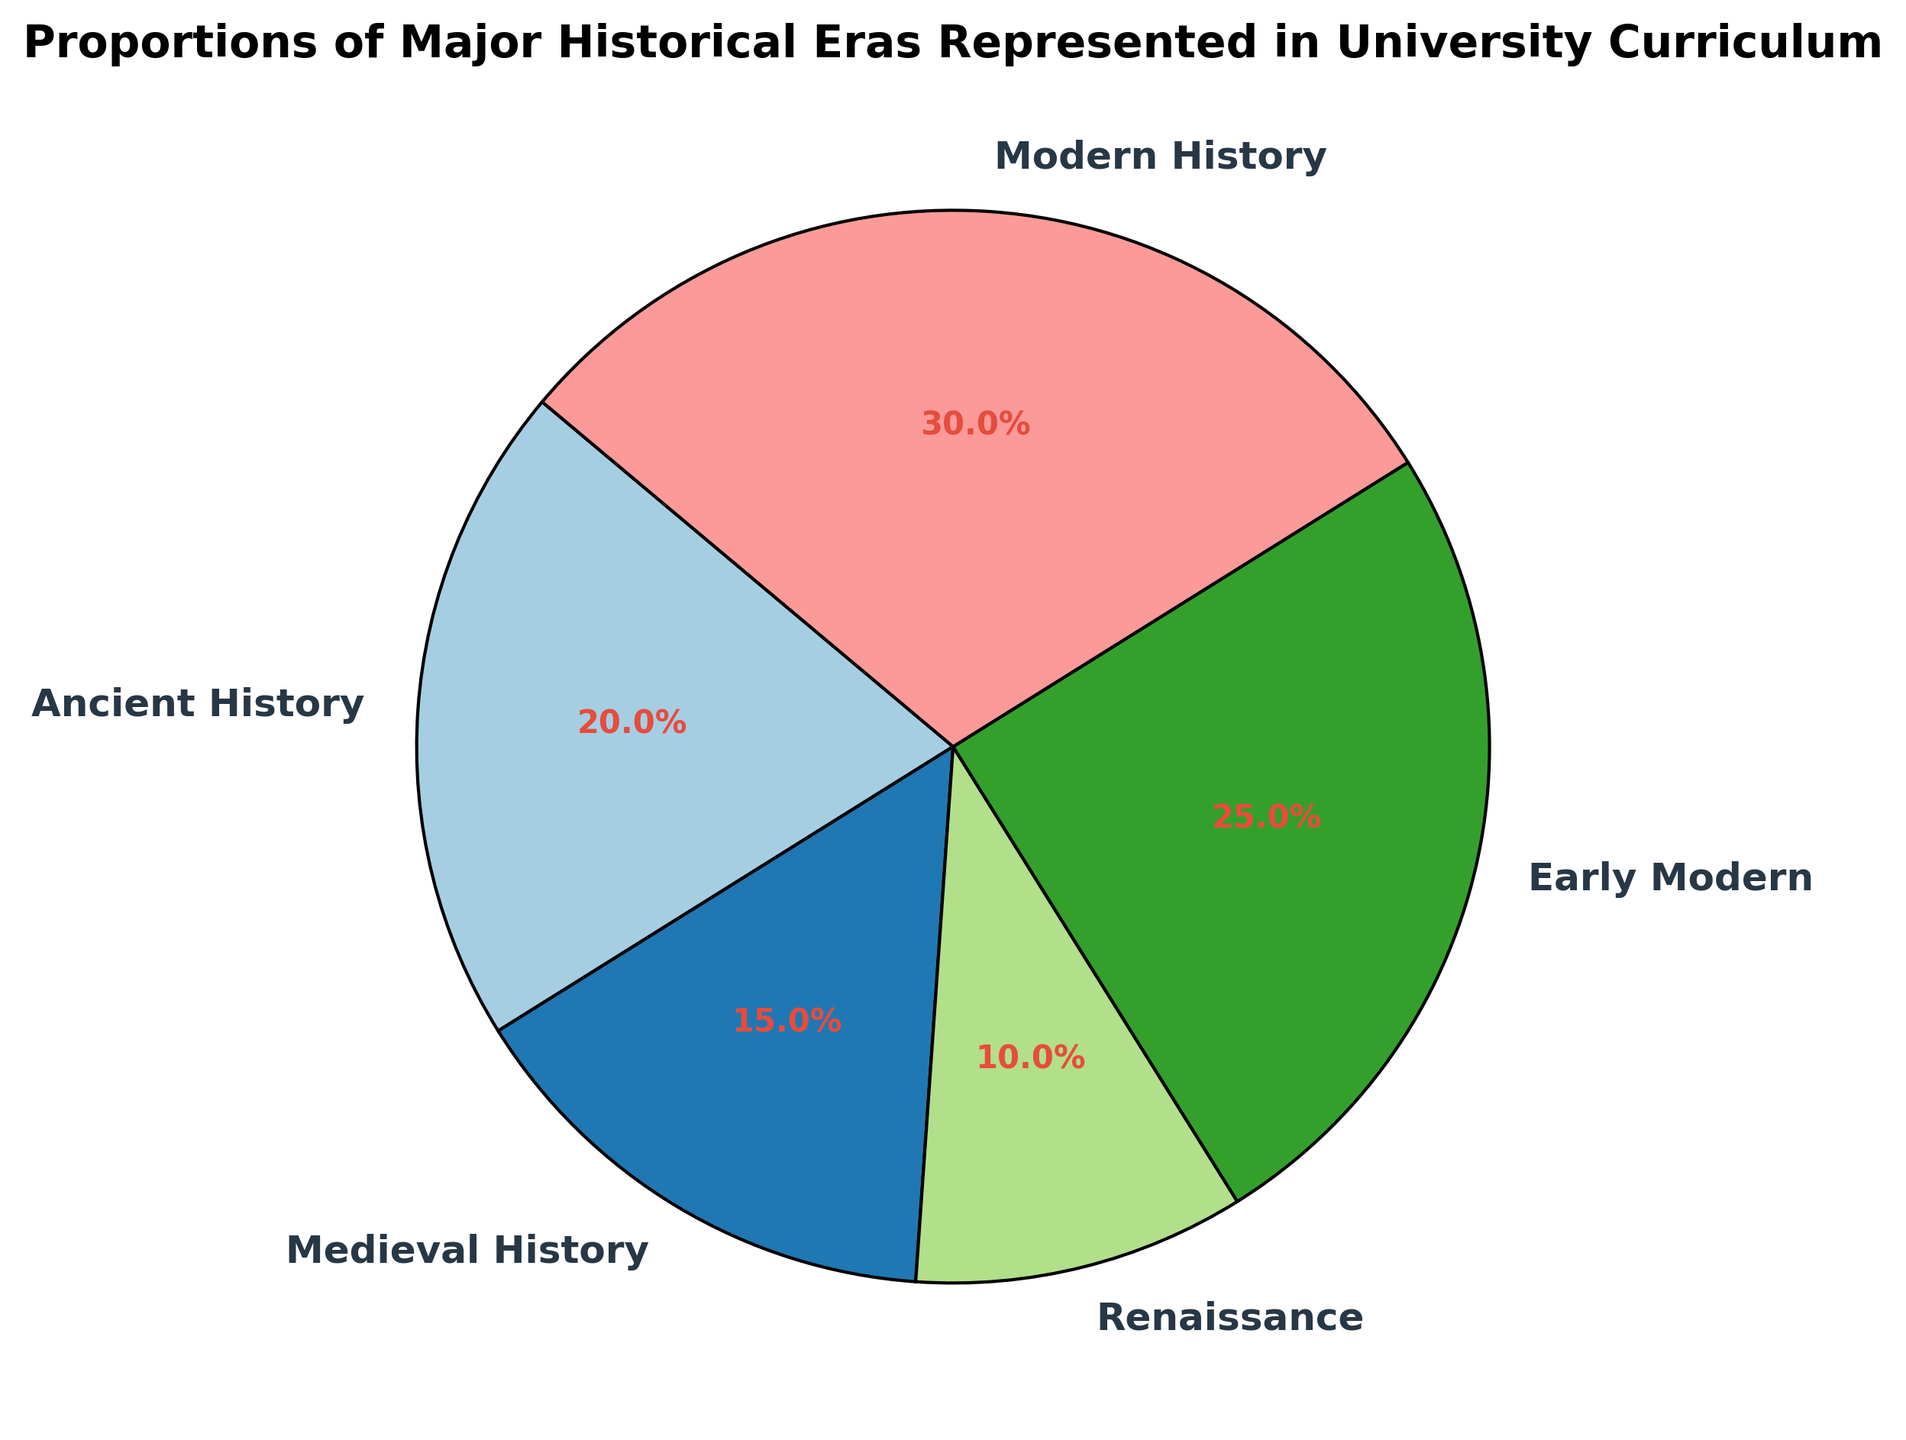What percentage of the curriculum is dedicated to the Renaissance era? The Renaissance era is represented by a segment in the pie chart labeled "Renaissance" with a percentage marked.
Answer: 10% Which era has the highest representation in the university curriculum? By examining each segment's label and percentage, the segment for "Modern History" has the highest percentage.
Answer: Modern History How much more is the proportion of Early Modern History compared to Medieval History? The chart shows Early Modern History at 25% and Medieval History at 15%. Subtract the proportion of Medieval History from Early Modern History: 25% - 15% = 10%.
Answer: 10% What is the combined proportion of Ancient and Medieval History in the curriculum? Sum the proportions of Ancient History (20%) and Medieval History (15%). 20% + 15% = 35%.
Answer: 35% Which era is depicted in a wedge that starts at a smaller angle compared to the others? The chart starts at angle 140, moving clockwise. The smallest angle corresponds to the Renaissance era as it has the smallest segment wedge starting closer to the start angle.
Answer: Renaissance How does the proportion of Ancient History compare to the proportion of Early Modern History? The chart indicates Ancient History at 20% and Early Modern History at 25%. Comparing these, the Early Modern History is greater.
Answer: Less than Early Modern Does any single era's representation constitute more than a quarter of the total curriculum? A quarter or 25% is the threshold. Modern History is at 30%, which is more than 25%. We can see this from the labeled segments.
Answer: Yes, Modern History What is the difference in representation between the least and the most represented era? The least represented is Renaissance at 10%, and the most represented is Modern History at 30%. The difference is 30% - 10% = 20%.
Answer: 20% Which two eras have the closest percentages of representation? Comparing the segments' values:
- Ancient History: 20%
- Medieval History: 15%
- Renaissance: 10%
- Early Modern: 25%
- Modern History: 30%
Medieval History and Ancient History have the closest percentages with a difference of 5%.
Answer: Ancient History and Medieval History 